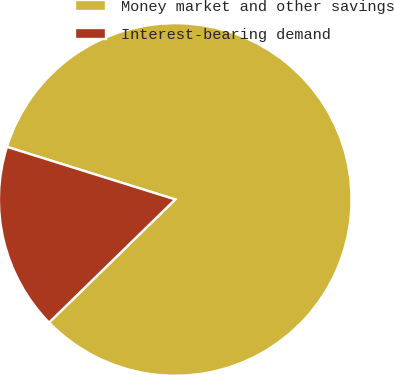Convert chart to OTSL. <chart><loc_0><loc_0><loc_500><loc_500><pie_chart><fcel>Money market and other savings<fcel>Interest-bearing demand<nl><fcel>82.87%<fcel>17.13%<nl></chart> 